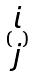<formula> <loc_0><loc_0><loc_500><loc_500>( \begin{matrix} i \\ j \end{matrix} )</formula> 